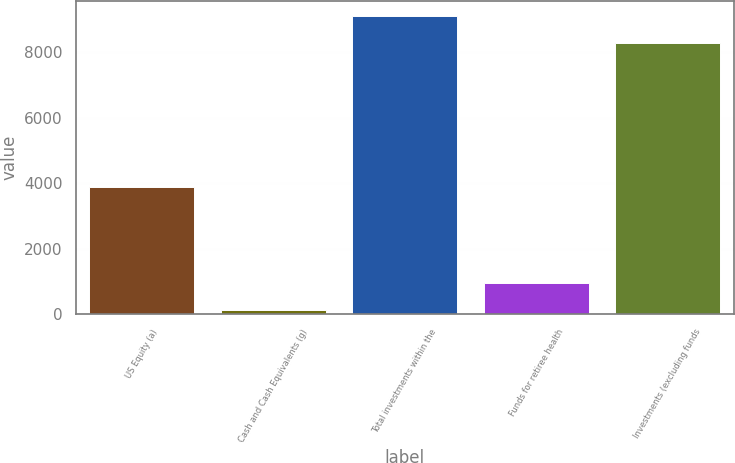Convert chart to OTSL. <chart><loc_0><loc_0><loc_500><loc_500><bar_chart><fcel>US Equity (a)<fcel>Cash and Cash Equivalents (g)<fcel>Total investments within the<fcel>Funds for retiree health<fcel>Investments (excluding funds<nl><fcel>3872<fcel>124<fcel>9099.2<fcel>955.2<fcel>8268<nl></chart> 